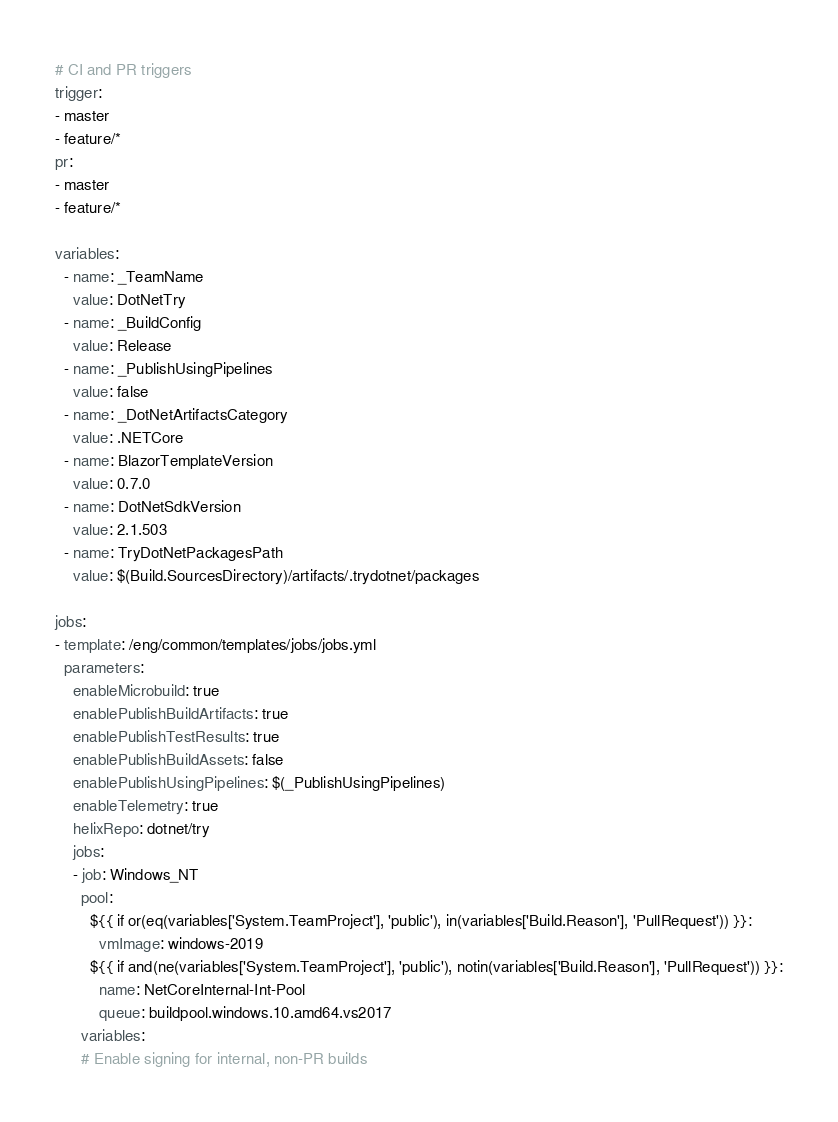Convert code to text. <code><loc_0><loc_0><loc_500><loc_500><_YAML_># CI and PR triggers
trigger:
- master
- feature/*
pr:
- master
- feature/*

variables:
  - name: _TeamName
    value: DotNetTry
  - name: _BuildConfig
    value: Release
  - name: _PublishUsingPipelines
    value: false
  - name: _DotNetArtifactsCategory
    value: .NETCore
  - name: BlazorTemplateVersion
    value: 0.7.0
  - name: DotNetSdkVersion
    value: 2.1.503
  - name: TryDotNetPackagesPath
    value: $(Build.SourcesDirectory)/artifacts/.trydotnet/packages

jobs:
- template: /eng/common/templates/jobs/jobs.yml
  parameters:
    enableMicrobuild: true
    enablePublishBuildArtifacts: true
    enablePublishTestResults: true
    enablePublishBuildAssets: false
    enablePublishUsingPipelines: $(_PublishUsingPipelines)
    enableTelemetry: true
    helixRepo: dotnet/try
    jobs:
    - job: Windows_NT
      pool:
        ${{ if or(eq(variables['System.TeamProject'], 'public'), in(variables['Build.Reason'], 'PullRequest')) }}:
          vmImage: windows-2019
        ${{ if and(ne(variables['System.TeamProject'], 'public'), notin(variables['Build.Reason'], 'PullRequest')) }}:
          name: NetCoreInternal-Int-Pool
          queue: buildpool.windows.10.amd64.vs2017
      variables:
      # Enable signing for internal, non-PR builds</code> 